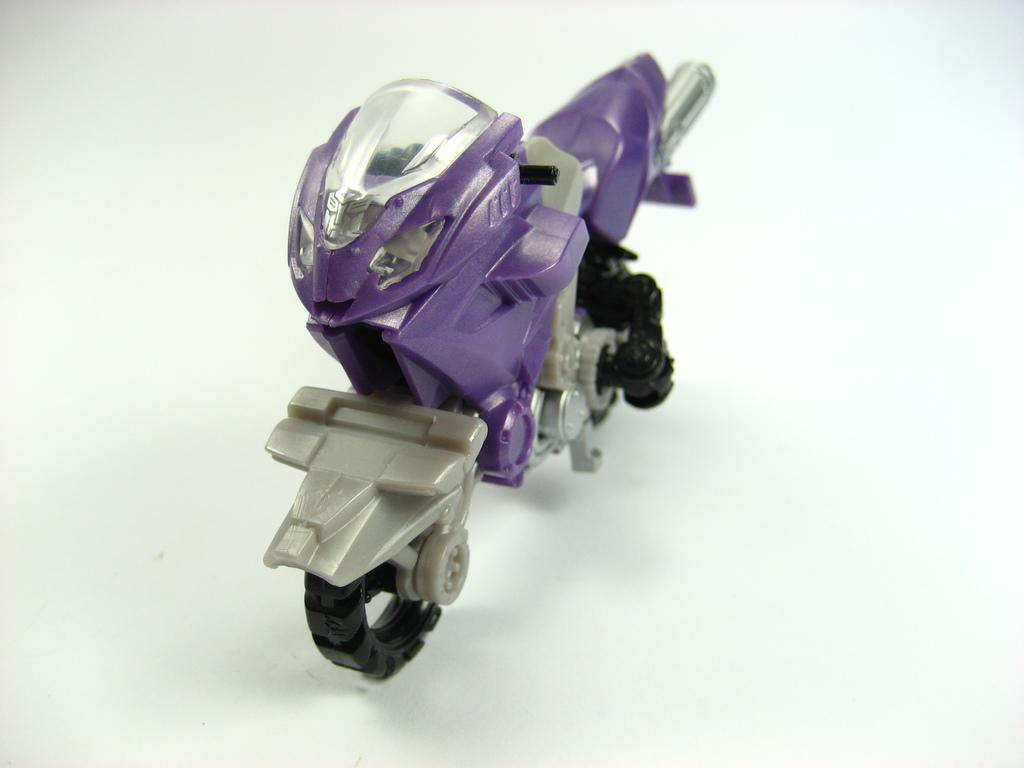What type of toy is featured in the image? There is a violet-colored bike toy in the image. What color is the bike toy? The bike toy is violet-colored. What can be seen in the background of the image? The background of the image is white. What type of machine is being used in the hospital in the image? There is no machine or hospital present in the image; it features a violet-colored bike toy with a white background. Can you tell me who made the request for the bike toy in the image? There is no indication of a request or a person making a request in the image; it simply shows a violet-colored bike toy with a white background. 